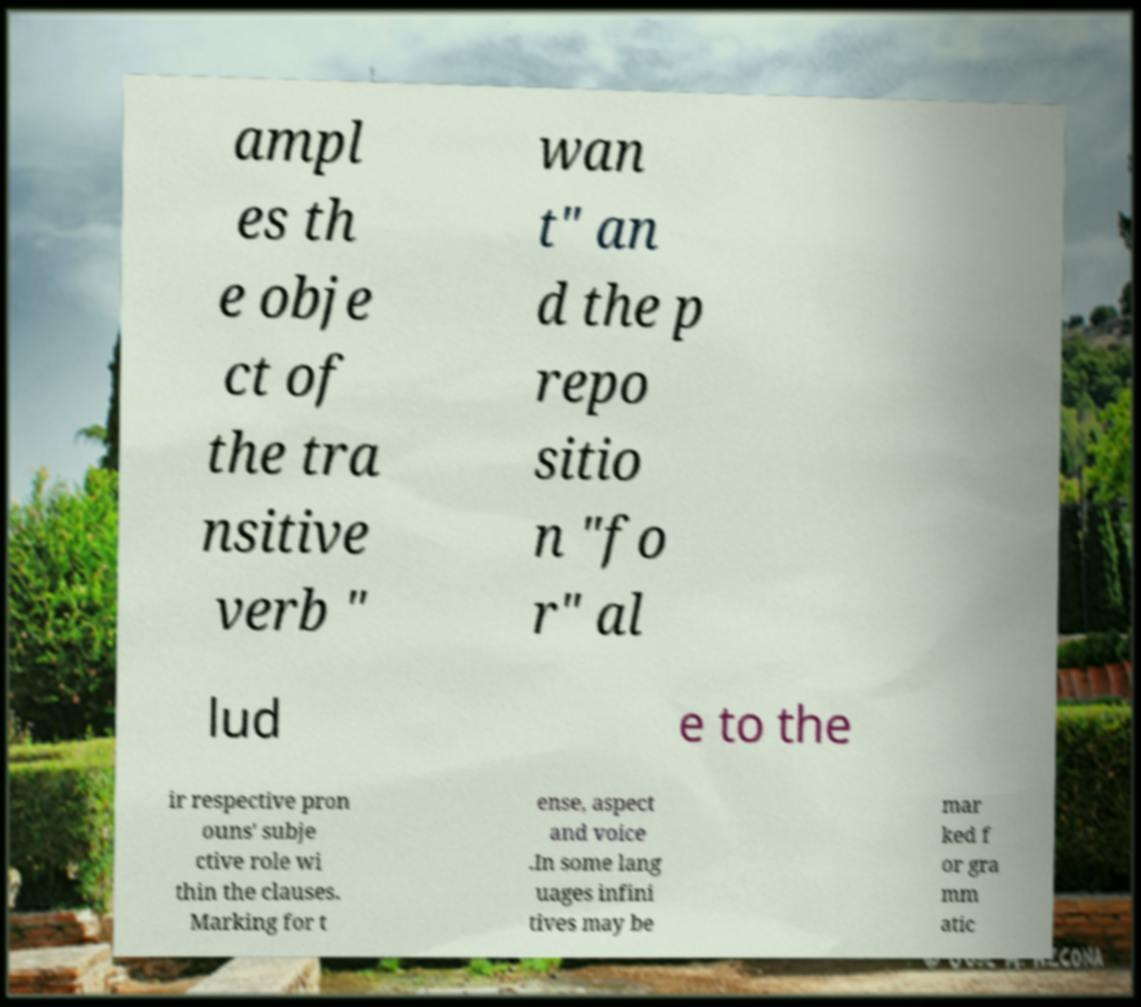Can you read and provide the text displayed in the image?This photo seems to have some interesting text. Can you extract and type it out for me? ampl es th e obje ct of the tra nsitive verb " wan t" an d the p repo sitio n "fo r" al lud e to the ir respective pron ouns' subje ctive role wi thin the clauses. Marking for t ense, aspect and voice .In some lang uages infini tives may be mar ked f or gra mm atic 